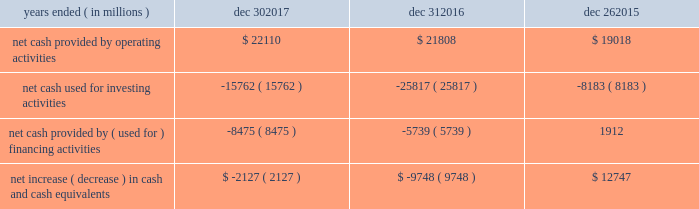In summary , our cash flows for each period were as follows : years ended ( in millions ) dec 30 , dec 31 , dec 26 .
Operating activities cash provided by operating activities is net income adjusted for certain non-cash items and changes in assets and liabilities .
For 2017 compared to 2016 , the $ 302 million increase in cash provided by operating activities was due to changes to working capital partially offset by adjustments for non-cash items and lower net income .
Tax reform did not have an impact on our 2017 cash provided by operating activities .
The increase in cash provided by operating activities was driven by increased income before taxes and $ 1.0 billion receipts of customer deposits .
These increases were partially offset by increased inventory and accounts receivable .
Income taxes paid , net of refunds , in 2017 compared to 2016 were $ 2.9 billion higher due to higher income before taxes , taxable gains on sales of asml , and taxes on the isecg divestiture .
We expect approximately $ 2.0 billion of additional customer deposits in 2018 .
For 2016 compared to 2015 , the $ 2.8 billion increase in cash provided by operating activities was due to adjustments for non-cash items and changes in working capital , partially offset by lower net income .
The adjustments for non-cash items were higher in 2016 primarily due to restructuring and other charges and the change in deferred taxes , partially offset by lower depreciation .
Investing activities investing cash flows consist primarily of capital expenditures ; investment purchases , sales , maturities , and disposals ; and proceeds from divestitures and cash used for acquisitions .
Our capital expenditures were $ 11.8 billion in 2017 ( $ 9.6 billion in 2016 and $ 7.3 billion in 2015 ) .
The decrease in cash used for investing activities in 2017 compared to 2016 was primarily due to higher net activity of available-for sale-investments in 2017 , proceeds from our divestiture of isecg in 2017 , and higher maturities and sales of trading assets in 2017 .
This activity was partially offset by higher capital expenditures in 2017 .
The increase in cash used for investing activities in 2016 compared to 2015 was primarily due to our completed acquisition of altera , net purchases of trading assets in 2016 compared to net sales of trading assets in 2015 , and higher capital expenditures in 2016 .
This increase was partially offset by lower investments in non-marketable equity investments .
Financing activities financing cash flows consist primarily of repurchases of common stock , payment of dividends to stockholders , issuance and repayment of short-term and long-term debt , and proceeds from the sale of shares of common stock through employee equity incentive plans .
The increase in cash used for financing activities in 2017 compared to 2016 was primarily due to net long-term debt activity , which was a use of cash in 2017 compared to a source of cash in 2016 .
During 2017 , we repurchased $ 3.6 billion of common stock under our authorized common stock repurchase program , compared to $ 2.6 billion in 2016 .
As of december 30 , 2017 , $ 13.2 billion remained available for repurchasing common stock under the existing repurchase authorization limit .
We base our level of common stock repurchases on internal cash management decisions , and this level may fluctuate .
Proceeds from the sale of common stock through employee equity incentive plans totaled $ 770 million in 2017 compared to $ 1.1 billion in 2016 .
Our total dividend payments were $ 5.1 billion in 2017 compared to $ 4.9 billion in 2016 .
We have paid a cash dividend in each of the past 101 quarters .
In january 2018 , our board of directors approved an increase to our cash dividend to $ 1.20 per share on an annual basis .
The board has declared a quarterly cash dividend of $ 0.30 per share of common stock for q1 2018 .
The dividend is payable on march 1 , 2018 to stockholders of record on february 7 , 2018 .
Cash was used for financing activities in 2016 compared to cash provided by financing activities in 2015 , primarily due to fewer debt issuances and the repayment of debt in 2016 .
This activity was partially offset by repayment of commercial paper in 2015 and fewer common stock repurchases in 2016 .
Md&a - results of operations consolidated results and analysis 37 .
What was the percentage change in net cash provided by operating activities from 2015 to 2016? 
Computations: ((21808 - 19018) / 19018)
Answer: 0.1467. 